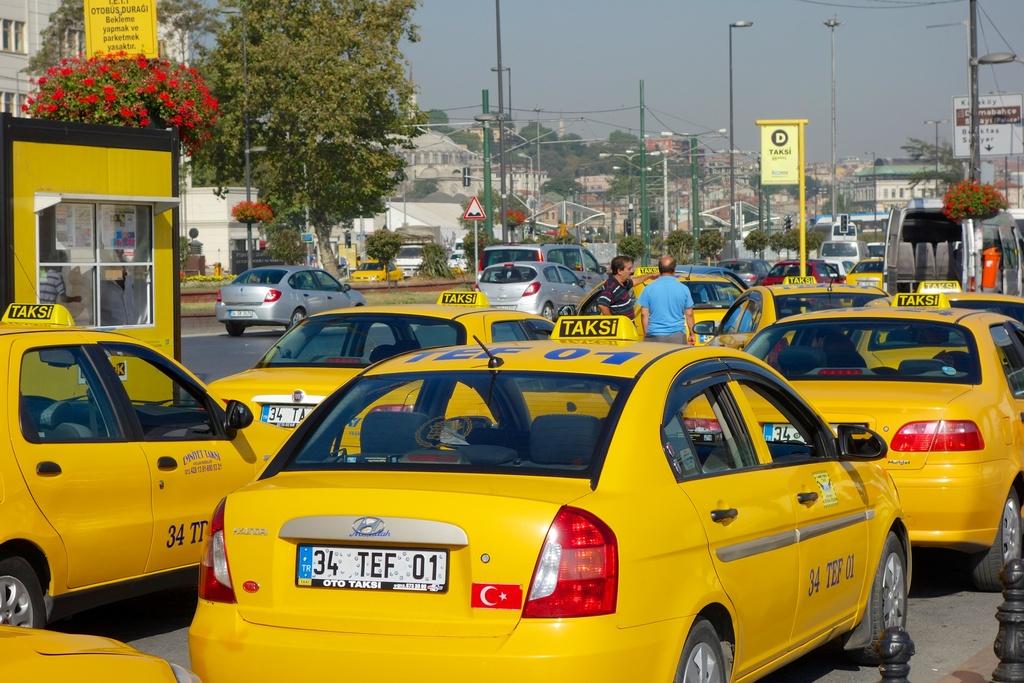What does the text on the top of the yellow car say?
Offer a terse response. Taksi. What is the lisencse of the taxi?
Provide a succinct answer. 34 tef 01. 